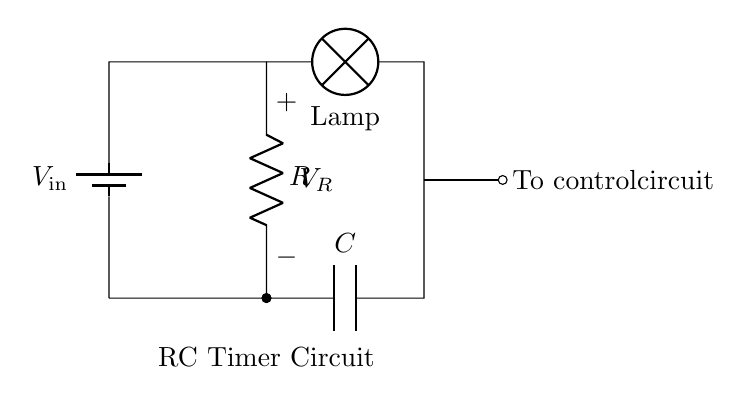What is the power source for this circuit? The power source is a battery, indicated by the symbol in the circuit with a label of V_in.
Answer: battery What type of components are R and C? R is a resistor and C is a capacitor, which are typical components used in timing circuits.
Answer: resistor and capacitor What does the lamp represent in this circuit? The lamp represents the load that will be controlled by the RC timer circuit, turning on or off based on the timer functionality.
Answer: load What function does the capacitor (C) serve in this circuit? The capacitor stores and releases electrical energy, impacting the timing mechanism of the auto-shutoff feature.
Answer: timing How does the resistor (R) affect the timing? The resistor regulates the charging and discharging rate of the capacitor, determining the timing duration for the auto-shutoff feature.
Answer: timing duration What is represented by the control circuit connection in the diagram? The control circuit connection indicates where the output of the timer is linked to control the lamp or other circuits, signifying its operational role.
Answer: control output 